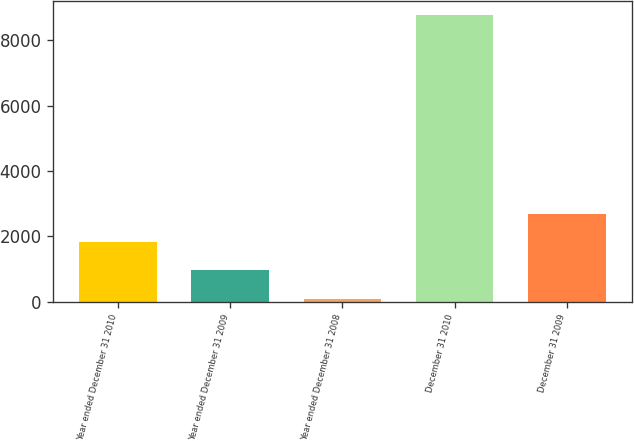<chart> <loc_0><loc_0><loc_500><loc_500><bar_chart><fcel>Year ended December 31 2010<fcel>Year ended December 31 2009<fcel>Year ended December 31 2008<fcel>December 31 2010<fcel>December 31 2009<nl><fcel>1832.34<fcel>966.57<fcel>100.8<fcel>8758.5<fcel>2698.11<nl></chart> 